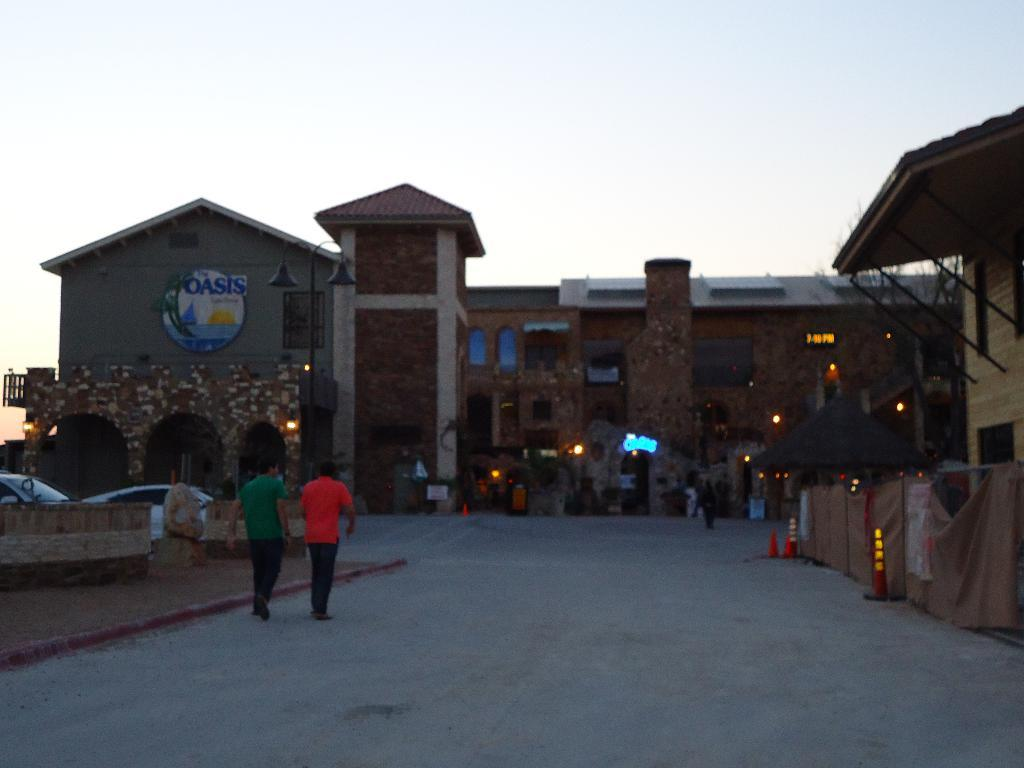What are the two men in the image doing? The two men in the image are walking on the road. Where are the men located in the image? The men are on the left side of the image. What can be seen in the middle of the image? There is a building with lights in the middle of the image. What is visible at the top of the image? The sky is visible at the top of the image. What type of music is the son playing in the image? There is no son or music present in the image; it features two men walking on the road and a building with lights. Where is the spot where the men are walking in the image? The men are walking on the road, which is on the left side of the image. 